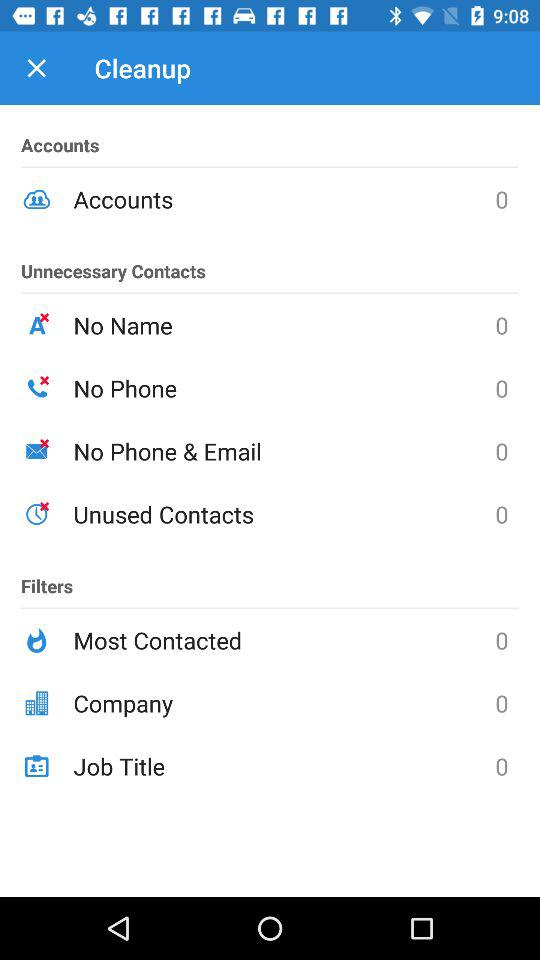What is the count for the job title? The count for the job title is 0. 